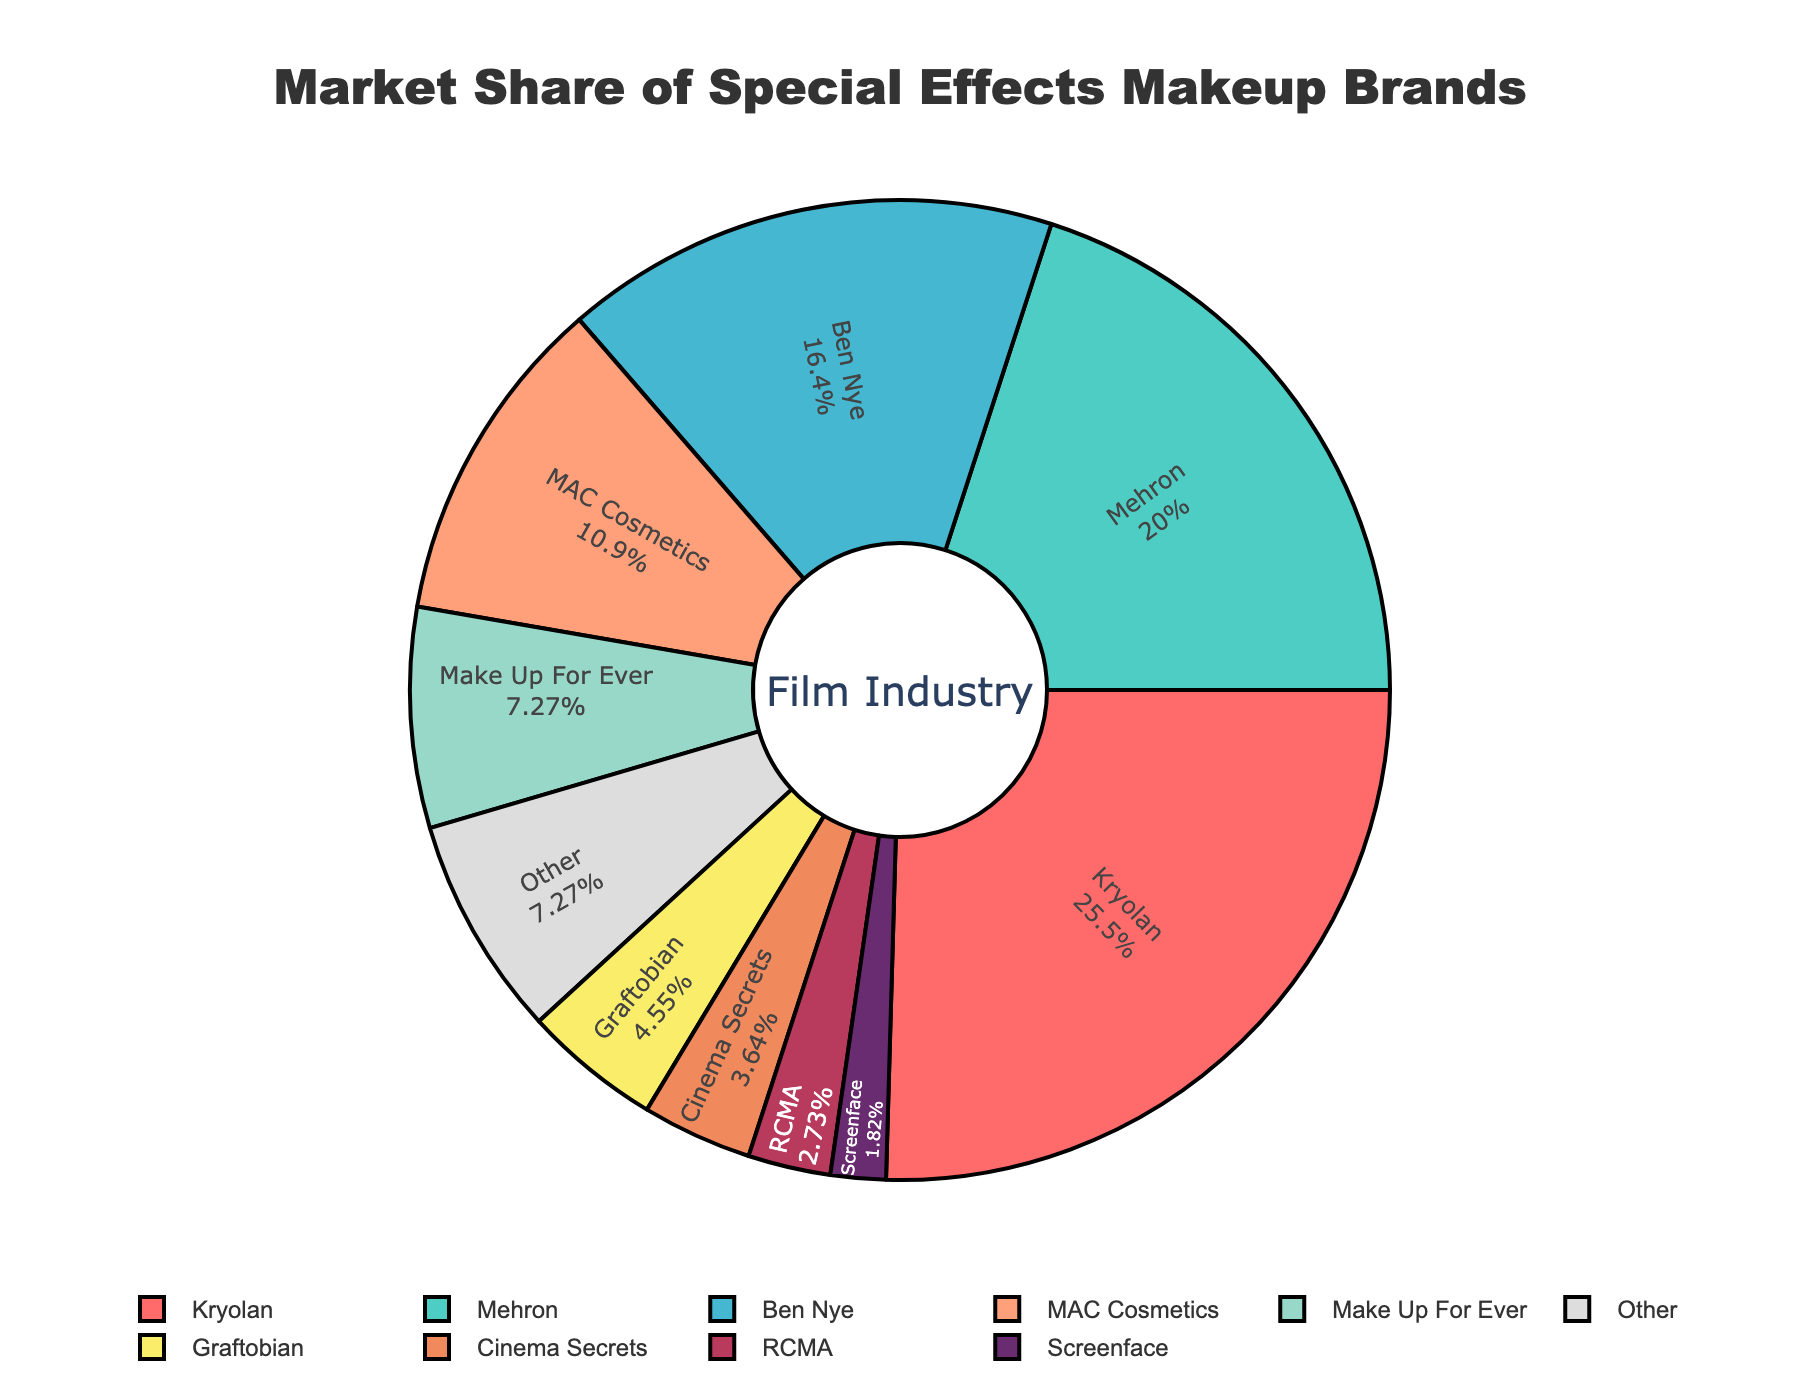What is the market share of Kryolan? Identify Kryolan's segment and read the percentage inside it.
Answer: 28% How much larger is Mehron's market share compared to Cinema Secrets'? Mehron has 22% and Cinema Secrets has 4%, subtract the latter from the former: 22% - 4% = 18%.
Answer: 18% Which brand has the smallest market share and what is it? Identify the segment labeled Screenface and read the percentage inside it.
Answer: Screenface, 2% What is the combined market share of Make Up For Ever and Graftobian? Sum the percentages of Make Up For Ever (8%) and Graftobian (5%): 8% + 5% = 13%.
Answer: 13% What is the market share difference between Ben Nye and MAC Cosmetics? Subtract MAC's share (12%) from Ben Nye's share (18%): 18% - 12% = 6%.
Answer: 6% How does the market share of brands with less than 10% each compare to the total market share of all other brands? Calculate the sum of shares for RCMA, Screenface, Cinema Secrets, Graftobian, Make Up For Ever, and Other (3% + 2% + 4% + 5% + 8% + 8% = 30%), then calculate the sum of the shares for Kryolan, Mehron, Ben Nye, and MAC (28% + 22% + 18% + 12% = 80%). 30% is less than 80%.
Answer: Less than Which brand's segment is colored red? The first color in the palette (red) corresponds to the first brand in the data, which is Kryolan.
Answer: Kryolan What percent of the market is held by brands other than the leading three (Kryolan, Mehron, Ben Nye)? Subtract the sum of the top three shares (28% + 22% + 18% = 68%) from 100%: 100% - 68% = 32%.
Answer: 32% What is the visual difference in color between MAC Cosmetics and RCMA's segments? MAC Cosmetics has a coral color (fourth color in the palette) and RCMA's segment is gray (last color in the palette).
Answer: MAC Cosmetics: coral, RCMA: gray 